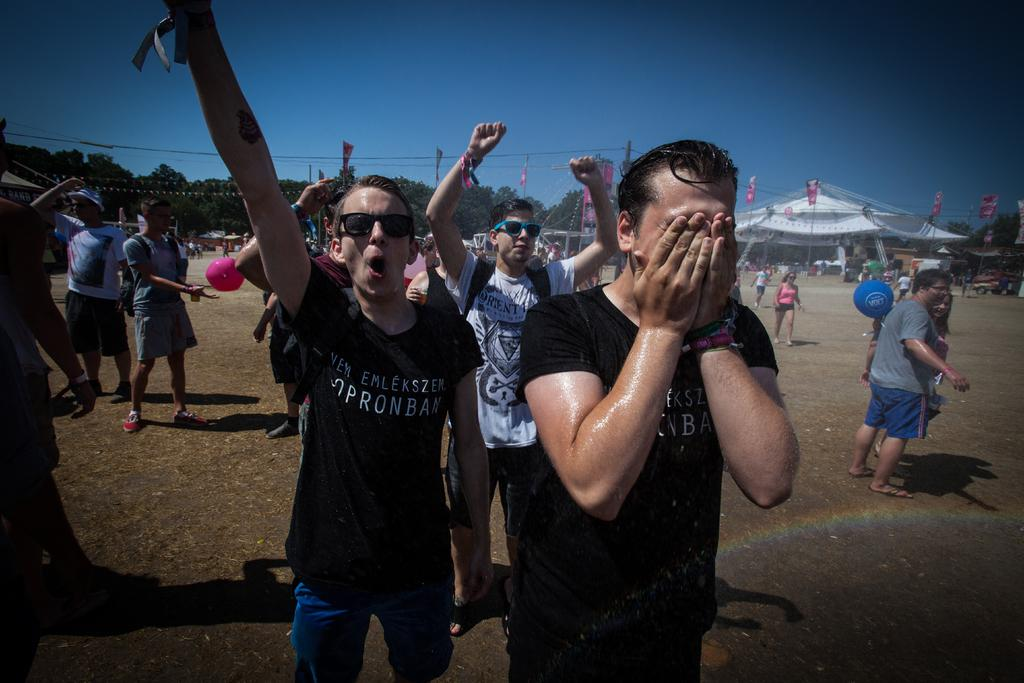Who or what is present in the image? There are people in the image. What can be seen in the background of the image? There is a tent and flags attached to poles in the background of the image. What type of vegetation is visible in the image? There are trees visible in the image. What is visible at the top of the image? The sky is visible at the top of the image. What type of corn is being served in the image? There is no corn present in the image. Can you tell me how the hospital is related to the image? There is no mention of a hospital in the image or the provided facts. 